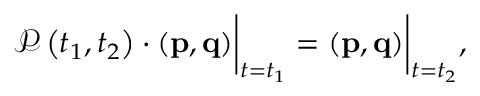<formula> <loc_0><loc_0><loc_500><loc_500>\begin{array} { r } { \mathcal { P } \left ( t _ { 1 } , t _ { 2 } \right ) \cdot \left ( p , q \right ) \left | _ { t = t _ { 1 } } = \left ( p , q \right ) \right | _ { t = t _ { 2 } } , } \end{array}</formula> 